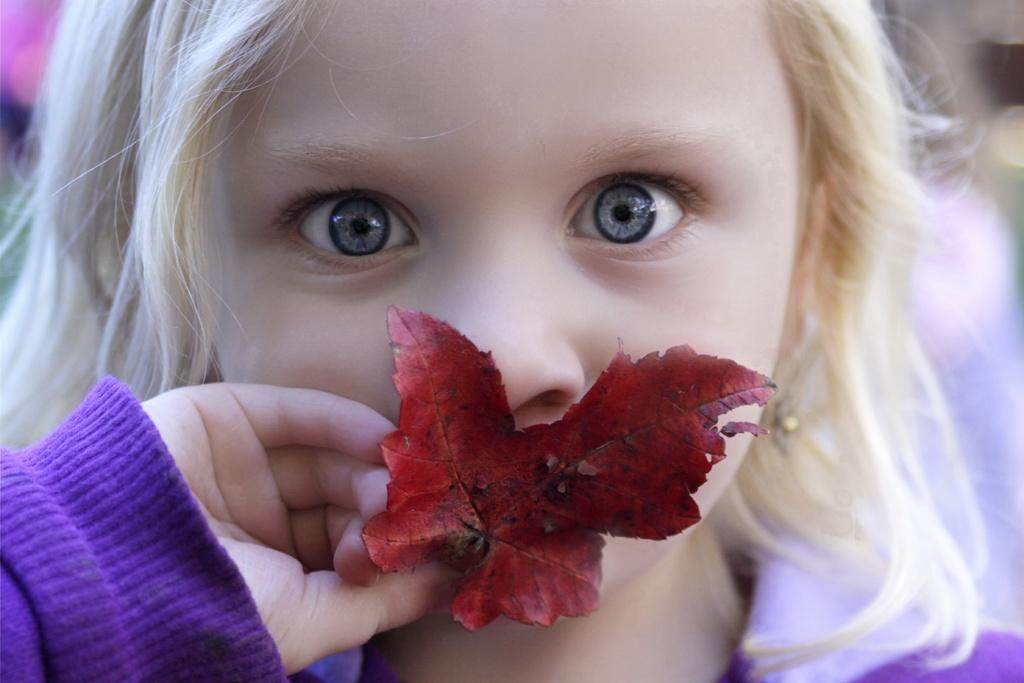Who is the main subject in the image? There is a girl in the image. What is the girl holding in the image? The girl is holding a leaf. Can you describe the background of the image? The background of the image is blurred. What type of air can be seen coming out of the girl's mouth in the image? There is no air coming out of the girl's mouth in the image. What border is visible around the girl in the image? There is no border visible around the girl in the image. 